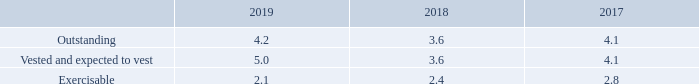Stock options weighted average remaining contractual terms (in years) information at December 31, for the years 2019, 2018, and 2017 is as follows:
As of December 31, 2019, total unrecognized expense related to non-vested restricted stock unit awards and stock options was $45 million, and is expected to be recognized over a weighted average period of 1.8 years.
What was the total unrecognized expense related to non-vested restricted stock unit awards and stock options in 2019? $45 million. How long is the total unrecognized expense related to non-vested restricted stock unit awards and stock options expected to be recognized? Over a weighted average period of 1.8 years. In which years is information on Stock options weighted average remaining contractual terms provided? 2019, 2018, 2017. In which year was the Exercisable amount the largest? 2.8>2.4>2.1
Answer: 2017. What was the change in the Exercisable amount in 2019 from 2018? 2.1-2.4
Answer: -0.3. What was the percentage change in the Exercisable amount in 2019 from 2018?
Answer scale should be: percent. (2.1-2.4)/2.4
Answer: -12.5. 